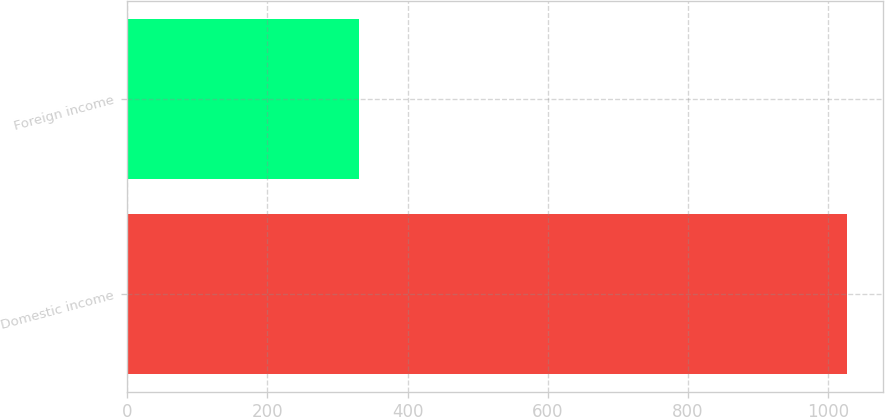<chart> <loc_0><loc_0><loc_500><loc_500><bar_chart><fcel>Domestic income<fcel>Foreign income<nl><fcel>1027<fcel>330<nl></chart> 